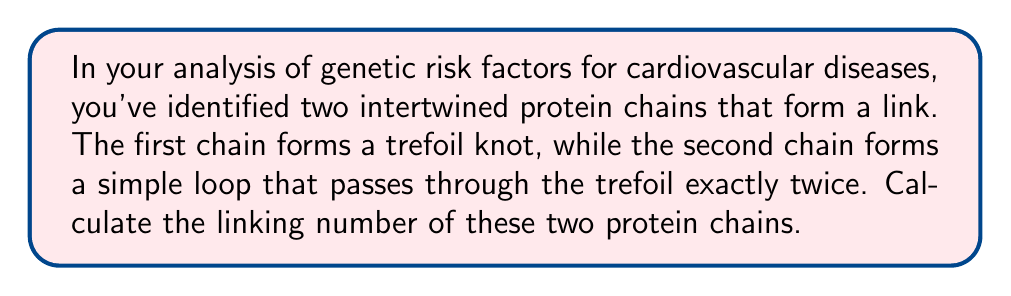Solve this math problem. To calculate the linking number of two intertwined protein chains, we need to follow these steps:

1) First, we need to understand what the linking number represents. The linking number is a topological invariant that measures how many times one curve winds around another in three-dimensional space.

2) For a trefoil knot linked with a simple loop, we can use the following formula:

   $$Lk = \frac{1}{2}\sum_{i} \epsilon_i$$

   where $Lk$ is the linking number, and $\epsilon_i$ is the sign (+1 or -1) of each crossing between the two chains.

3) In this case, we have a trefoil knot (the first protein chain) and a simple loop (the second protein chain) that passes through the trefoil twice. Let's visualize this:

   [asy]
   import graph;
   size(200);
   pen p = rgb(0,0,1);
   pen q = rgb(1,0,0);
   draw((0,0)..(1,1)..(2,0)..(1,-1)..cycle, p);
   draw((0.5,0.5)..(1.5,-0.5), q);
   draw((1.5,0.5)..(0.5,-0.5), q);
   [/asy]

4) We need to count the crossings between the red line (simple loop) and the blue curve (trefoil knot). There are two crossings.

5) Now, we need to determine the sign of each crossing. The sign is positive if the overcrossing strand can be rotated counterclockwise to align with the undercrossing strand, and negative otherwise.

6) In this case, both crossings have the same sign (let's say positive). So we have:

   $$\epsilon_1 = +1, \epsilon_2 = +1$$

7) Applying the formula:

   $$Lk = \frac{1}{2}(+1 + 1) = 1$$

Therefore, the linking number of these two protein chains is 1.
Answer: 1 